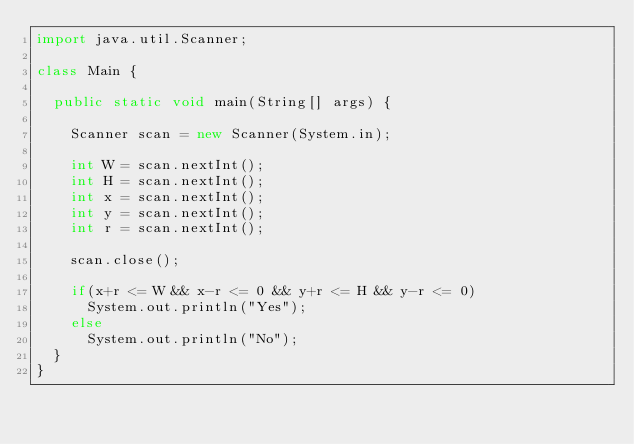<code> <loc_0><loc_0><loc_500><loc_500><_Java_>import java.util.Scanner;

class Main {

	public static void main(String[] args) {

		Scanner scan = new Scanner(System.in);

		int W = scan.nextInt();
		int H = scan.nextInt();
		int x = scan.nextInt();
		int y = scan.nextInt();
		int r = scan.nextInt();
		
		scan.close();

		if(x+r <= W && x-r <= 0 && y+r <= H && y-r <= 0)
			System.out.println("Yes");
		else
			System.out.println("No");
	}
}</code> 